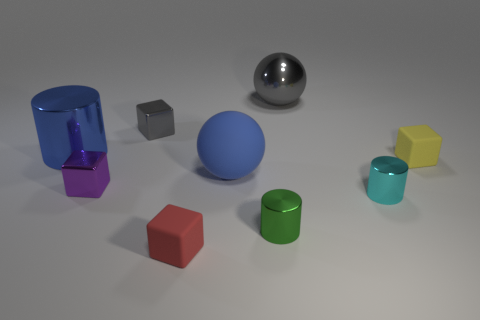Which object stands out the most to you in terms of color, and why? The cyan cylinder stands out the most concerning color as it has a vibrant and saturated hue that contrasts strongly with the neutral background and the other objects' more subdued colors. 